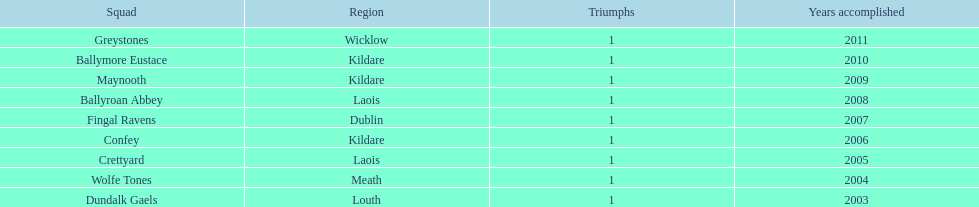What is the last team on the chart Dundalk Gaels. 